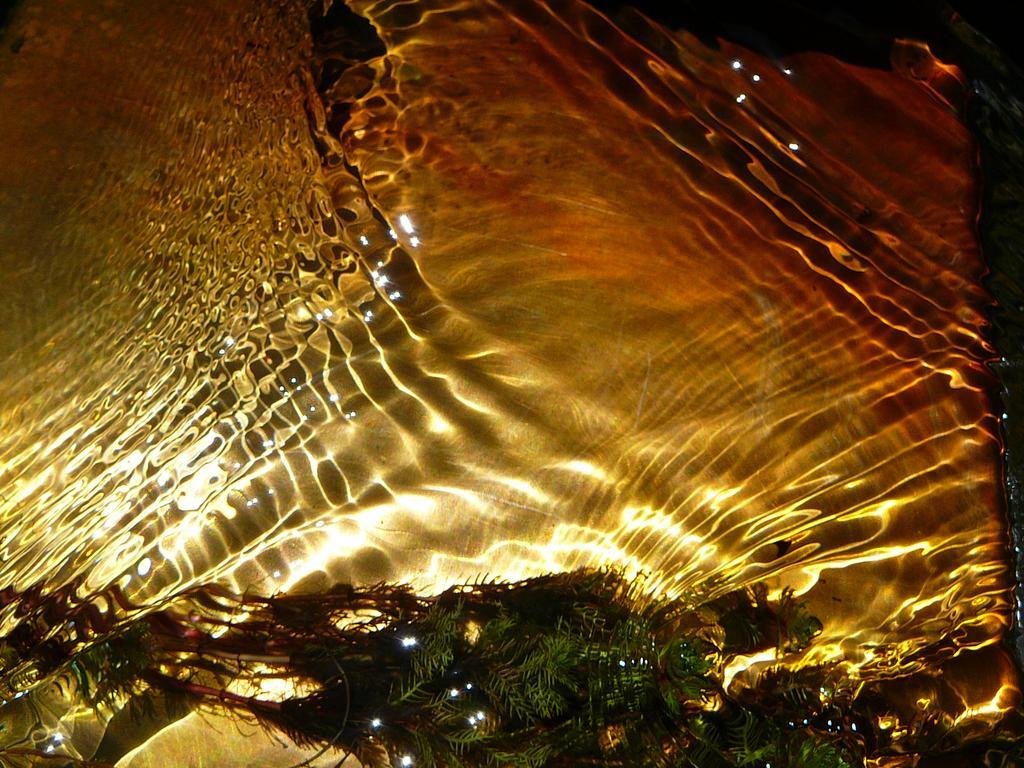Please provide a concise description of this image. In the image there is water flowing and in the front it seems to be a plant in it. 